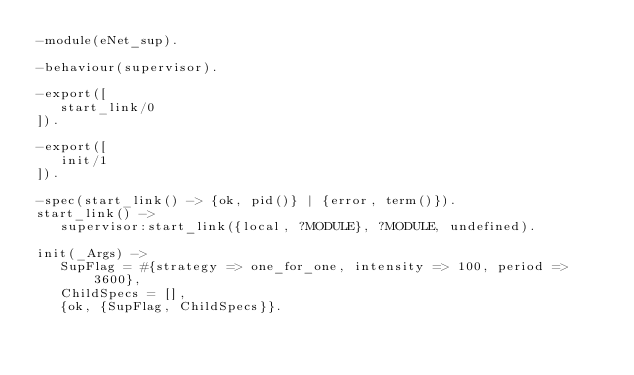Convert code to text. <code><loc_0><loc_0><loc_500><loc_500><_Erlang_>-module(eNet_sup).

-behaviour(supervisor).

-export([
   start_link/0
]).

-export([
   init/1
]).

-spec(start_link() -> {ok, pid()} | {error, term()}).
start_link() ->
   supervisor:start_link({local, ?MODULE}, ?MODULE, undefined).

init(_Args) ->
   SupFlag = #{strategy => one_for_one, intensity => 100, period => 3600},
   ChildSpecs = [],
   {ok, {SupFlag, ChildSpecs}}.
</code> 